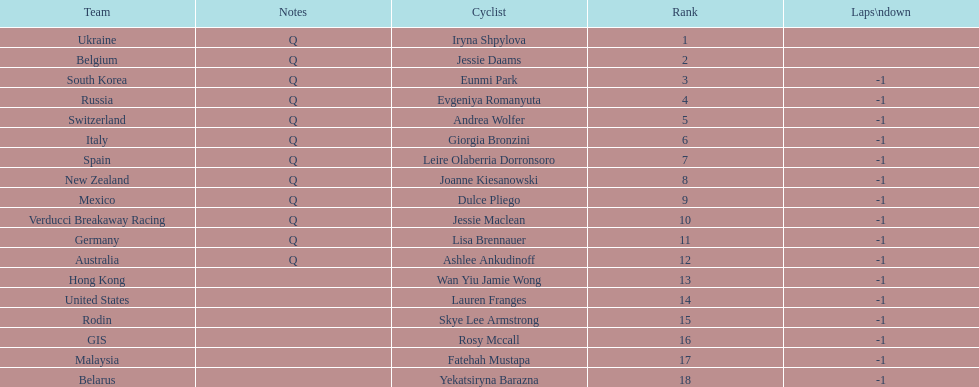Could you parse the entire table? {'header': ['Team', 'Notes', 'Cyclist', 'Rank', 'Laps\\ndown'], 'rows': [['Ukraine', 'Q', 'Iryna Shpylova', '1', ''], ['Belgium', 'Q', 'Jessie Daams', '2', ''], ['South Korea', 'Q', 'Eunmi Park', '3', '-1'], ['Russia', 'Q', 'Evgeniya Romanyuta', '4', '-1'], ['Switzerland', 'Q', 'Andrea Wolfer', '5', '-1'], ['Italy', 'Q', 'Giorgia Bronzini', '6', '-1'], ['Spain', 'Q', 'Leire Olaberria Dorronsoro', '7', '-1'], ['New Zealand', 'Q', 'Joanne Kiesanowski', '8', '-1'], ['Mexico', 'Q', 'Dulce Pliego', '9', '-1'], ['Verducci Breakaway Racing', 'Q', 'Jessie Maclean', '10', '-1'], ['Germany', 'Q', 'Lisa Brennauer', '11', '-1'], ['Australia', 'Q', 'Ashlee Ankudinoff', '12', '-1'], ['Hong Kong', '', 'Wan Yiu Jamie Wong', '13', '-1'], ['United States', '', 'Lauren Franges', '14', '-1'], ['Rodin', '', 'Skye Lee Armstrong', '15', '-1'], ['GIS', '', 'Rosy Mccall', '16', '-1'], ['Malaysia', '', 'Fatehah Mustapa', '17', '-1'], ['Belarus', '', 'Yekatsiryna Barazna', '18', '-1']]} How many cyclist are not listed with a country team? 3. 